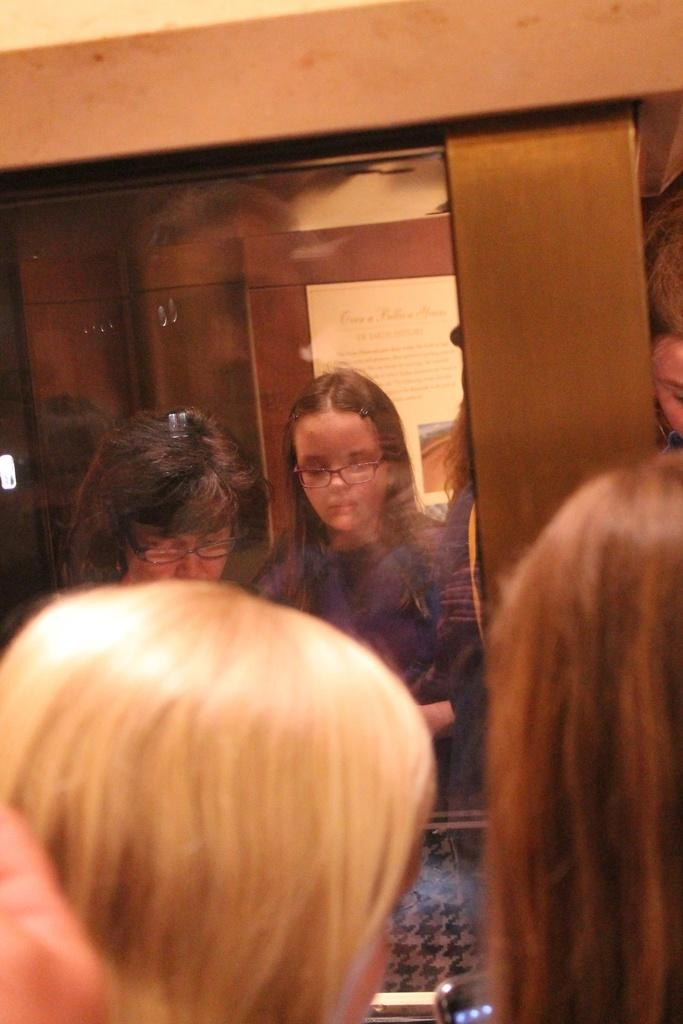What can be seen in the image involving people? There are people standing in the image. What object is present that is typically used for communication? There is a mobile in the image. What reflective surface is visible in the image? There is a mirror in the image. What type of furniture is present in the image? There are cupboards in the image. What decorative item is visible on a wall in the image? There is a poster in the image. What type of vegetable is being used as a decoration on the poster in the image? There is no vegetable present on the poster in the image; it is a decorative item without any vegetables. Can you tell me how many books are stacked on the cupboards in the image? There is no mention of books in the image; only a mobile, a mirror, cupboards, and a poster are present. 